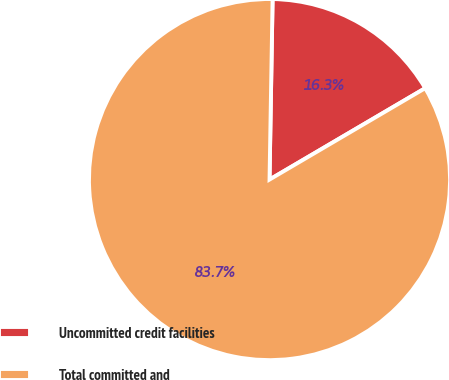<chart> <loc_0><loc_0><loc_500><loc_500><pie_chart><fcel>Uncommitted credit facilities<fcel>Total committed and<nl><fcel>16.28%<fcel>83.72%<nl></chart> 